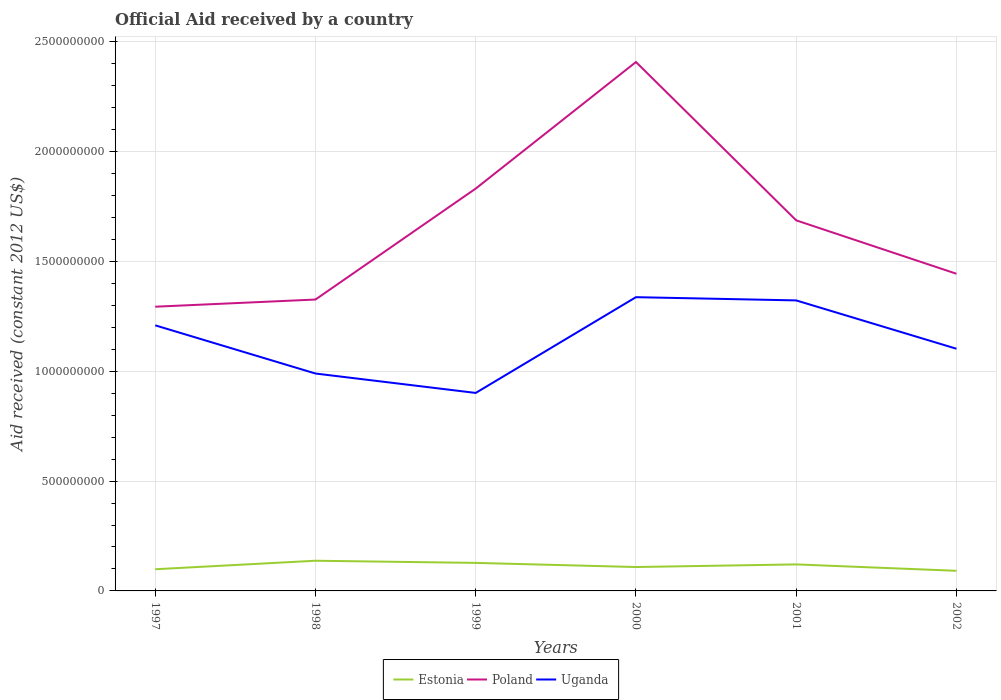How many different coloured lines are there?
Offer a very short reply. 3. Does the line corresponding to Estonia intersect with the line corresponding to Uganda?
Your answer should be compact. No. Across all years, what is the maximum net official aid received in Poland?
Make the answer very short. 1.29e+09. What is the total net official aid received in Poland in the graph?
Ensure brevity in your answer.  -3.93e+08. What is the difference between the highest and the second highest net official aid received in Estonia?
Give a very brief answer. 4.58e+07. Is the net official aid received in Poland strictly greater than the net official aid received in Uganda over the years?
Offer a very short reply. No. What is the difference between two consecutive major ticks on the Y-axis?
Offer a terse response. 5.00e+08. Does the graph contain any zero values?
Offer a very short reply. No. Does the graph contain grids?
Provide a succinct answer. Yes. How many legend labels are there?
Your response must be concise. 3. What is the title of the graph?
Offer a very short reply. Official Aid received by a country. Does "Finland" appear as one of the legend labels in the graph?
Provide a succinct answer. No. What is the label or title of the Y-axis?
Give a very brief answer. Aid received (constant 2012 US$). What is the Aid received (constant 2012 US$) in Estonia in 1997?
Make the answer very short. 9.87e+07. What is the Aid received (constant 2012 US$) of Poland in 1997?
Make the answer very short. 1.29e+09. What is the Aid received (constant 2012 US$) of Uganda in 1997?
Your response must be concise. 1.21e+09. What is the Aid received (constant 2012 US$) of Estonia in 1998?
Provide a short and direct response. 1.37e+08. What is the Aid received (constant 2012 US$) of Poland in 1998?
Your answer should be compact. 1.33e+09. What is the Aid received (constant 2012 US$) in Uganda in 1998?
Provide a short and direct response. 9.90e+08. What is the Aid received (constant 2012 US$) in Estonia in 1999?
Your response must be concise. 1.28e+08. What is the Aid received (constant 2012 US$) in Poland in 1999?
Your answer should be compact. 1.83e+09. What is the Aid received (constant 2012 US$) in Uganda in 1999?
Ensure brevity in your answer.  9.01e+08. What is the Aid received (constant 2012 US$) in Estonia in 2000?
Keep it short and to the point. 1.09e+08. What is the Aid received (constant 2012 US$) of Poland in 2000?
Your answer should be compact. 2.41e+09. What is the Aid received (constant 2012 US$) of Uganda in 2000?
Your answer should be very brief. 1.34e+09. What is the Aid received (constant 2012 US$) of Estonia in 2001?
Your answer should be very brief. 1.21e+08. What is the Aid received (constant 2012 US$) in Poland in 2001?
Your response must be concise. 1.69e+09. What is the Aid received (constant 2012 US$) in Uganda in 2001?
Your answer should be compact. 1.32e+09. What is the Aid received (constant 2012 US$) of Estonia in 2002?
Provide a short and direct response. 9.16e+07. What is the Aid received (constant 2012 US$) in Poland in 2002?
Your answer should be very brief. 1.44e+09. What is the Aid received (constant 2012 US$) of Uganda in 2002?
Give a very brief answer. 1.10e+09. Across all years, what is the maximum Aid received (constant 2012 US$) in Estonia?
Offer a terse response. 1.37e+08. Across all years, what is the maximum Aid received (constant 2012 US$) of Poland?
Your answer should be very brief. 2.41e+09. Across all years, what is the maximum Aid received (constant 2012 US$) of Uganda?
Offer a terse response. 1.34e+09. Across all years, what is the minimum Aid received (constant 2012 US$) of Estonia?
Give a very brief answer. 9.16e+07. Across all years, what is the minimum Aid received (constant 2012 US$) in Poland?
Give a very brief answer. 1.29e+09. Across all years, what is the minimum Aid received (constant 2012 US$) of Uganda?
Keep it short and to the point. 9.01e+08. What is the total Aid received (constant 2012 US$) of Estonia in the graph?
Give a very brief answer. 6.85e+08. What is the total Aid received (constant 2012 US$) in Poland in the graph?
Offer a very short reply. 9.99e+09. What is the total Aid received (constant 2012 US$) in Uganda in the graph?
Give a very brief answer. 6.86e+09. What is the difference between the Aid received (constant 2012 US$) in Estonia in 1997 and that in 1998?
Provide a short and direct response. -3.88e+07. What is the difference between the Aid received (constant 2012 US$) in Poland in 1997 and that in 1998?
Your answer should be compact. -3.26e+07. What is the difference between the Aid received (constant 2012 US$) in Uganda in 1997 and that in 1998?
Offer a terse response. 2.19e+08. What is the difference between the Aid received (constant 2012 US$) of Estonia in 1997 and that in 1999?
Your answer should be very brief. -2.89e+07. What is the difference between the Aid received (constant 2012 US$) in Poland in 1997 and that in 1999?
Your answer should be very brief. -5.38e+08. What is the difference between the Aid received (constant 2012 US$) of Uganda in 1997 and that in 1999?
Keep it short and to the point. 3.08e+08. What is the difference between the Aid received (constant 2012 US$) of Estonia in 1997 and that in 2000?
Keep it short and to the point. -1.00e+07. What is the difference between the Aid received (constant 2012 US$) of Poland in 1997 and that in 2000?
Make the answer very short. -1.11e+09. What is the difference between the Aid received (constant 2012 US$) of Uganda in 1997 and that in 2000?
Give a very brief answer. -1.28e+08. What is the difference between the Aid received (constant 2012 US$) in Estonia in 1997 and that in 2001?
Give a very brief answer. -2.20e+07. What is the difference between the Aid received (constant 2012 US$) of Poland in 1997 and that in 2001?
Provide a succinct answer. -3.93e+08. What is the difference between the Aid received (constant 2012 US$) of Uganda in 1997 and that in 2001?
Your answer should be compact. -1.14e+08. What is the difference between the Aid received (constant 2012 US$) in Estonia in 1997 and that in 2002?
Offer a very short reply. 7.07e+06. What is the difference between the Aid received (constant 2012 US$) of Poland in 1997 and that in 2002?
Offer a very short reply. -1.50e+08. What is the difference between the Aid received (constant 2012 US$) of Uganda in 1997 and that in 2002?
Your answer should be compact. 1.07e+08. What is the difference between the Aid received (constant 2012 US$) in Estonia in 1998 and that in 1999?
Provide a short and direct response. 9.86e+06. What is the difference between the Aid received (constant 2012 US$) in Poland in 1998 and that in 1999?
Provide a succinct answer. -5.05e+08. What is the difference between the Aid received (constant 2012 US$) of Uganda in 1998 and that in 1999?
Keep it short and to the point. 8.84e+07. What is the difference between the Aid received (constant 2012 US$) of Estonia in 1998 and that in 2000?
Provide a short and direct response. 2.87e+07. What is the difference between the Aid received (constant 2012 US$) of Poland in 1998 and that in 2000?
Your answer should be very brief. -1.08e+09. What is the difference between the Aid received (constant 2012 US$) of Uganda in 1998 and that in 2000?
Provide a succinct answer. -3.48e+08. What is the difference between the Aid received (constant 2012 US$) of Estonia in 1998 and that in 2001?
Offer a very short reply. 1.67e+07. What is the difference between the Aid received (constant 2012 US$) in Poland in 1998 and that in 2001?
Provide a succinct answer. -3.60e+08. What is the difference between the Aid received (constant 2012 US$) in Uganda in 1998 and that in 2001?
Your response must be concise. -3.33e+08. What is the difference between the Aid received (constant 2012 US$) in Estonia in 1998 and that in 2002?
Your response must be concise. 4.58e+07. What is the difference between the Aid received (constant 2012 US$) in Poland in 1998 and that in 2002?
Keep it short and to the point. -1.17e+08. What is the difference between the Aid received (constant 2012 US$) in Uganda in 1998 and that in 2002?
Provide a short and direct response. -1.13e+08. What is the difference between the Aid received (constant 2012 US$) in Estonia in 1999 and that in 2000?
Provide a succinct answer. 1.88e+07. What is the difference between the Aid received (constant 2012 US$) in Poland in 1999 and that in 2000?
Provide a short and direct response. -5.76e+08. What is the difference between the Aid received (constant 2012 US$) of Uganda in 1999 and that in 2000?
Offer a terse response. -4.36e+08. What is the difference between the Aid received (constant 2012 US$) in Estonia in 1999 and that in 2001?
Offer a very short reply. 6.84e+06. What is the difference between the Aid received (constant 2012 US$) of Poland in 1999 and that in 2001?
Keep it short and to the point. 1.45e+08. What is the difference between the Aid received (constant 2012 US$) in Uganda in 1999 and that in 2001?
Keep it short and to the point. -4.21e+08. What is the difference between the Aid received (constant 2012 US$) in Estonia in 1999 and that in 2002?
Keep it short and to the point. 3.60e+07. What is the difference between the Aid received (constant 2012 US$) in Poland in 1999 and that in 2002?
Provide a short and direct response. 3.88e+08. What is the difference between the Aid received (constant 2012 US$) of Uganda in 1999 and that in 2002?
Provide a succinct answer. -2.01e+08. What is the difference between the Aid received (constant 2012 US$) of Estonia in 2000 and that in 2001?
Offer a very short reply. -1.20e+07. What is the difference between the Aid received (constant 2012 US$) of Poland in 2000 and that in 2001?
Your answer should be compact. 7.21e+08. What is the difference between the Aid received (constant 2012 US$) of Uganda in 2000 and that in 2001?
Provide a short and direct response. 1.48e+07. What is the difference between the Aid received (constant 2012 US$) of Estonia in 2000 and that in 2002?
Offer a very short reply. 1.71e+07. What is the difference between the Aid received (constant 2012 US$) of Poland in 2000 and that in 2002?
Offer a terse response. 9.64e+08. What is the difference between the Aid received (constant 2012 US$) of Uganda in 2000 and that in 2002?
Offer a terse response. 2.35e+08. What is the difference between the Aid received (constant 2012 US$) of Estonia in 2001 and that in 2002?
Your answer should be compact. 2.91e+07. What is the difference between the Aid received (constant 2012 US$) of Poland in 2001 and that in 2002?
Ensure brevity in your answer.  2.43e+08. What is the difference between the Aid received (constant 2012 US$) in Uganda in 2001 and that in 2002?
Your answer should be compact. 2.20e+08. What is the difference between the Aid received (constant 2012 US$) in Estonia in 1997 and the Aid received (constant 2012 US$) in Poland in 1998?
Make the answer very short. -1.23e+09. What is the difference between the Aid received (constant 2012 US$) in Estonia in 1997 and the Aid received (constant 2012 US$) in Uganda in 1998?
Provide a short and direct response. -8.91e+08. What is the difference between the Aid received (constant 2012 US$) of Poland in 1997 and the Aid received (constant 2012 US$) of Uganda in 1998?
Ensure brevity in your answer.  3.04e+08. What is the difference between the Aid received (constant 2012 US$) of Estonia in 1997 and the Aid received (constant 2012 US$) of Poland in 1999?
Provide a short and direct response. -1.73e+09. What is the difference between the Aid received (constant 2012 US$) in Estonia in 1997 and the Aid received (constant 2012 US$) in Uganda in 1999?
Your answer should be compact. -8.03e+08. What is the difference between the Aid received (constant 2012 US$) of Poland in 1997 and the Aid received (constant 2012 US$) of Uganda in 1999?
Your response must be concise. 3.93e+08. What is the difference between the Aid received (constant 2012 US$) of Estonia in 1997 and the Aid received (constant 2012 US$) of Poland in 2000?
Your answer should be very brief. -2.31e+09. What is the difference between the Aid received (constant 2012 US$) in Estonia in 1997 and the Aid received (constant 2012 US$) in Uganda in 2000?
Provide a short and direct response. -1.24e+09. What is the difference between the Aid received (constant 2012 US$) of Poland in 1997 and the Aid received (constant 2012 US$) of Uganda in 2000?
Keep it short and to the point. -4.34e+07. What is the difference between the Aid received (constant 2012 US$) of Estonia in 1997 and the Aid received (constant 2012 US$) of Poland in 2001?
Make the answer very short. -1.59e+09. What is the difference between the Aid received (constant 2012 US$) in Estonia in 1997 and the Aid received (constant 2012 US$) in Uganda in 2001?
Offer a very short reply. -1.22e+09. What is the difference between the Aid received (constant 2012 US$) in Poland in 1997 and the Aid received (constant 2012 US$) in Uganda in 2001?
Make the answer very short. -2.86e+07. What is the difference between the Aid received (constant 2012 US$) in Estonia in 1997 and the Aid received (constant 2012 US$) in Poland in 2002?
Your answer should be compact. -1.35e+09. What is the difference between the Aid received (constant 2012 US$) of Estonia in 1997 and the Aid received (constant 2012 US$) of Uganda in 2002?
Offer a very short reply. -1.00e+09. What is the difference between the Aid received (constant 2012 US$) in Poland in 1997 and the Aid received (constant 2012 US$) in Uganda in 2002?
Ensure brevity in your answer.  1.91e+08. What is the difference between the Aid received (constant 2012 US$) of Estonia in 1998 and the Aid received (constant 2012 US$) of Poland in 1999?
Make the answer very short. -1.69e+09. What is the difference between the Aid received (constant 2012 US$) in Estonia in 1998 and the Aid received (constant 2012 US$) in Uganda in 1999?
Provide a succinct answer. -7.64e+08. What is the difference between the Aid received (constant 2012 US$) of Poland in 1998 and the Aid received (constant 2012 US$) of Uganda in 1999?
Give a very brief answer. 4.25e+08. What is the difference between the Aid received (constant 2012 US$) in Estonia in 1998 and the Aid received (constant 2012 US$) in Poland in 2000?
Provide a succinct answer. -2.27e+09. What is the difference between the Aid received (constant 2012 US$) in Estonia in 1998 and the Aid received (constant 2012 US$) in Uganda in 2000?
Your answer should be very brief. -1.20e+09. What is the difference between the Aid received (constant 2012 US$) of Poland in 1998 and the Aid received (constant 2012 US$) of Uganda in 2000?
Your response must be concise. -1.07e+07. What is the difference between the Aid received (constant 2012 US$) in Estonia in 1998 and the Aid received (constant 2012 US$) in Poland in 2001?
Your answer should be compact. -1.55e+09. What is the difference between the Aid received (constant 2012 US$) of Estonia in 1998 and the Aid received (constant 2012 US$) of Uganda in 2001?
Your answer should be very brief. -1.19e+09. What is the difference between the Aid received (constant 2012 US$) in Poland in 1998 and the Aid received (constant 2012 US$) in Uganda in 2001?
Keep it short and to the point. 4.02e+06. What is the difference between the Aid received (constant 2012 US$) in Estonia in 1998 and the Aid received (constant 2012 US$) in Poland in 2002?
Offer a very short reply. -1.31e+09. What is the difference between the Aid received (constant 2012 US$) of Estonia in 1998 and the Aid received (constant 2012 US$) of Uganda in 2002?
Offer a very short reply. -9.65e+08. What is the difference between the Aid received (constant 2012 US$) of Poland in 1998 and the Aid received (constant 2012 US$) of Uganda in 2002?
Make the answer very short. 2.24e+08. What is the difference between the Aid received (constant 2012 US$) in Estonia in 1999 and the Aid received (constant 2012 US$) in Poland in 2000?
Offer a terse response. -2.28e+09. What is the difference between the Aid received (constant 2012 US$) of Estonia in 1999 and the Aid received (constant 2012 US$) of Uganda in 2000?
Offer a terse response. -1.21e+09. What is the difference between the Aid received (constant 2012 US$) of Poland in 1999 and the Aid received (constant 2012 US$) of Uganda in 2000?
Your response must be concise. 4.94e+08. What is the difference between the Aid received (constant 2012 US$) in Estonia in 1999 and the Aid received (constant 2012 US$) in Poland in 2001?
Offer a very short reply. -1.56e+09. What is the difference between the Aid received (constant 2012 US$) of Estonia in 1999 and the Aid received (constant 2012 US$) of Uganda in 2001?
Make the answer very short. -1.20e+09. What is the difference between the Aid received (constant 2012 US$) in Poland in 1999 and the Aid received (constant 2012 US$) in Uganda in 2001?
Give a very brief answer. 5.09e+08. What is the difference between the Aid received (constant 2012 US$) in Estonia in 1999 and the Aid received (constant 2012 US$) in Poland in 2002?
Offer a very short reply. -1.32e+09. What is the difference between the Aid received (constant 2012 US$) of Estonia in 1999 and the Aid received (constant 2012 US$) of Uganda in 2002?
Your response must be concise. -9.75e+08. What is the difference between the Aid received (constant 2012 US$) of Poland in 1999 and the Aid received (constant 2012 US$) of Uganda in 2002?
Ensure brevity in your answer.  7.29e+08. What is the difference between the Aid received (constant 2012 US$) in Estonia in 2000 and the Aid received (constant 2012 US$) in Poland in 2001?
Make the answer very short. -1.58e+09. What is the difference between the Aid received (constant 2012 US$) in Estonia in 2000 and the Aid received (constant 2012 US$) in Uganda in 2001?
Your response must be concise. -1.21e+09. What is the difference between the Aid received (constant 2012 US$) in Poland in 2000 and the Aid received (constant 2012 US$) in Uganda in 2001?
Make the answer very short. 1.09e+09. What is the difference between the Aid received (constant 2012 US$) of Estonia in 2000 and the Aid received (constant 2012 US$) of Poland in 2002?
Give a very brief answer. -1.34e+09. What is the difference between the Aid received (constant 2012 US$) of Estonia in 2000 and the Aid received (constant 2012 US$) of Uganda in 2002?
Offer a terse response. -9.94e+08. What is the difference between the Aid received (constant 2012 US$) of Poland in 2000 and the Aid received (constant 2012 US$) of Uganda in 2002?
Offer a terse response. 1.31e+09. What is the difference between the Aid received (constant 2012 US$) in Estonia in 2001 and the Aid received (constant 2012 US$) in Poland in 2002?
Your answer should be compact. -1.32e+09. What is the difference between the Aid received (constant 2012 US$) of Estonia in 2001 and the Aid received (constant 2012 US$) of Uganda in 2002?
Your response must be concise. -9.82e+08. What is the difference between the Aid received (constant 2012 US$) of Poland in 2001 and the Aid received (constant 2012 US$) of Uganda in 2002?
Your response must be concise. 5.85e+08. What is the average Aid received (constant 2012 US$) in Estonia per year?
Provide a short and direct response. 1.14e+08. What is the average Aid received (constant 2012 US$) in Poland per year?
Make the answer very short. 1.67e+09. What is the average Aid received (constant 2012 US$) in Uganda per year?
Your response must be concise. 1.14e+09. In the year 1997, what is the difference between the Aid received (constant 2012 US$) of Estonia and Aid received (constant 2012 US$) of Poland?
Provide a short and direct response. -1.20e+09. In the year 1997, what is the difference between the Aid received (constant 2012 US$) of Estonia and Aid received (constant 2012 US$) of Uganda?
Ensure brevity in your answer.  -1.11e+09. In the year 1997, what is the difference between the Aid received (constant 2012 US$) in Poland and Aid received (constant 2012 US$) in Uganda?
Keep it short and to the point. 8.49e+07. In the year 1998, what is the difference between the Aid received (constant 2012 US$) of Estonia and Aid received (constant 2012 US$) of Poland?
Keep it short and to the point. -1.19e+09. In the year 1998, what is the difference between the Aid received (constant 2012 US$) in Estonia and Aid received (constant 2012 US$) in Uganda?
Provide a succinct answer. -8.52e+08. In the year 1998, what is the difference between the Aid received (constant 2012 US$) of Poland and Aid received (constant 2012 US$) of Uganda?
Your answer should be compact. 3.37e+08. In the year 1999, what is the difference between the Aid received (constant 2012 US$) of Estonia and Aid received (constant 2012 US$) of Poland?
Keep it short and to the point. -1.70e+09. In the year 1999, what is the difference between the Aid received (constant 2012 US$) in Estonia and Aid received (constant 2012 US$) in Uganda?
Your answer should be very brief. -7.74e+08. In the year 1999, what is the difference between the Aid received (constant 2012 US$) in Poland and Aid received (constant 2012 US$) in Uganda?
Offer a very short reply. 9.30e+08. In the year 2000, what is the difference between the Aid received (constant 2012 US$) in Estonia and Aid received (constant 2012 US$) in Poland?
Provide a succinct answer. -2.30e+09. In the year 2000, what is the difference between the Aid received (constant 2012 US$) in Estonia and Aid received (constant 2012 US$) in Uganda?
Offer a very short reply. -1.23e+09. In the year 2000, what is the difference between the Aid received (constant 2012 US$) in Poland and Aid received (constant 2012 US$) in Uganda?
Keep it short and to the point. 1.07e+09. In the year 2001, what is the difference between the Aid received (constant 2012 US$) in Estonia and Aid received (constant 2012 US$) in Poland?
Make the answer very short. -1.57e+09. In the year 2001, what is the difference between the Aid received (constant 2012 US$) of Estonia and Aid received (constant 2012 US$) of Uganda?
Ensure brevity in your answer.  -1.20e+09. In the year 2001, what is the difference between the Aid received (constant 2012 US$) of Poland and Aid received (constant 2012 US$) of Uganda?
Your answer should be very brief. 3.64e+08. In the year 2002, what is the difference between the Aid received (constant 2012 US$) in Estonia and Aid received (constant 2012 US$) in Poland?
Make the answer very short. -1.35e+09. In the year 2002, what is the difference between the Aid received (constant 2012 US$) of Estonia and Aid received (constant 2012 US$) of Uganda?
Provide a succinct answer. -1.01e+09. In the year 2002, what is the difference between the Aid received (constant 2012 US$) of Poland and Aid received (constant 2012 US$) of Uganda?
Offer a very short reply. 3.41e+08. What is the ratio of the Aid received (constant 2012 US$) in Estonia in 1997 to that in 1998?
Your answer should be compact. 0.72. What is the ratio of the Aid received (constant 2012 US$) of Poland in 1997 to that in 1998?
Keep it short and to the point. 0.98. What is the ratio of the Aid received (constant 2012 US$) in Uganda in 1997 to that in 1998?
Your answer should be compact. 1.22. What is the ratio of the Aid received (constant 2012 US$) in Estonia in 1997 to that in 1999?
Offer a terse response. 0.77. What is the ratio of the Aid received (constant 2012 US$) in Poland in 1997 to that in 1999?
Your response must be concise. 0.71. What is the ratio of the Aid received (constant 2012 US$) in Uganda in 1997 to that in 1999?
Provide a succinct answer. 1.34. What is the ratio of the Aid received (constant 2012 US$) of Estonia in 1997 to that in 2000?
Your answer should be very brief. 0.91. What is the ratio of the Aid received (constant 2012 US$) in Poland in 1997 to that in 2000?
Offer a terse response. 0.54. What is the ratio of the Aid received (constant 2012 US$) of Uganda in 1997 to that in 2000?
Your answer should be very brief. 0.9. What is the ratio of the Aid received (constant 2012 US$) of Estonia in 1997 to that in 2001?
Keep it short and to the point. 0.82. What is the ratio of the Aid received (constant 2012 US$) of Poland in 1997 to that in 2001?
Your response must be concise. 0.77. What is the ratio of the Aid received (constant 2012 US$) of Uganda in 1997 to that in 2001?
Ensure brevity in your answer.  0.91. What is the ratio of the Aid received (constant 2012 US$) of Estonia in 1997 to that in 2002?
Offer a terse response. 1.08. What is the ratio of the Aid received (constant 2012 US$) of Poland in 1997 to that in 2002?
Ensure brevity in your answer.  0.9. What is the ratio of the Aid received (constant 2012 US$) of Uganda in 1997 to that in 2002?
Keep it short and to the point. 1.1. What is the ratio of the Aid received (constant 2012 US$) of Estonia in 1998 to that in 1999?
Your response must be concise. 1.08. What is the ratio of the Aid received (constant 2012 US$) of Poland in 1998 to that in 1999?
Offer a terse response. 0.72. What is the ratio of the Aid received (constant 2012 US$) in Uganda in 1998 to that in 1999?
Your answer should be very brief. 1.1. What is the ratio of the Aid received (constant 2012 US$) of Estonia in 1998 to that in 2000?
Offer a very short reply. 1.26. What is the ratio of the Aid received (constant 2012 US$) of Poland in 1998 to that in 2000?
Your answer should be compact. 0.55. What is the ratio of the Aid received (constant 2012 US$) of Uganda in 1998 to that in 2000?
Ensure brevity in your answer.  0.74. What is the ratio of the Aid received (constant 2012 US$) of Estonia in 1998 to that in 2001?
Offer a very short reply. 1.14. What is the ratio of the Aid received (constant 2012 US$) in Poland in 1998 to that in 2001?
Your response must be concise. 0.79. What is the ratio of the Aid received (constant 2012 US$) in Uganda in 1998 to that in 2001?
Give a very brief answer. 0.75. What is the ratio of the Aid received (constant 2012 US$) in Estonia in 1998 to that in 2002?
Your answer should be very brief. 1.5. What is the ratio of the Aid received (constant 2012 US$) in Poland in 1998 to that in 2002?
Offer a terse response. 0.92. What is the ratio of the Aid received (constant 2012 US$) in Uganda in 1998 to that in 2002?
Provide a succinct answer. 0.9. What is the ratio of the Aid received (constant 2012 US$) of Estonia in 1999 to that in 2000?
Offer a terse response. 1.17. What is the ratio of the Aid received (constant 2012 US$) of Poland in 1999 to that in 2000?
Give a very brief answer. 0.76. What is the ratio of the Aid received (constant 2012 US$) in Uganda in 1999 to that in 2000?
Offer a very short reply. 0.67. What is the ratio of the Aid received (constant 2012 US$) in Estonia in 1999 to that in 2001?
Ensure brevity in your answer.  1.06. What is the ratio of the Aid received (constant 2012 US$) in Poland in 1999 to that in 2001?
Provide a succinct answer. 1.09. What is the ratio of the Aid received (constant 2012 US$) in Uganda in 1999 to that in 2001?
Offer a terse response. 0.68. What is the ratio of the Aid received (constant 2012 US$) of Estonia in 1999 to that in 2002?
Give a very brief answer. 1.39. What is the ratio of the Aid received (constant 2012 US$) in Poland in 1999 to that in 2002?
Keep it short and to the point. 1.27. What is the ratio of the Aid received (constant 2012 US$) in Uganda in 1999 to that in 2002?
Offer a terse response. 0.82. What is the ratio of the Aid received (constant 2012 US$) of Estonia in 2000 to that in 2001?
Your answer should be compact. 0.9. What is the ratio of the Aid received (constant 2012 US$) of Poland in 2000 to that in 2001?
Offer a very short reply. 1.43. What is the ratio of the Aid received (constant 2012 US$) of Uganda in 2000 to that in 2001?
Provide a succinct answer. 1.01. What is the ratio of the Aid received (constant 2012 US$) of Estonia in 2000 to that in 2002?
Give a very brief answer. 1.19. What is the ratio of the Aid received (constant 2012 US$) of Poland in 2000 to that in 2002?
Offer a terse response. 1.67. What is the ratio of the Aid received (constant 2012 US$) of Uganda in 2000 to that in 2002?
Offer a terse response. 1.21. What is the ratio of the Aid received (constant 2012 US$) of Estonia in 2001 to that in 2002?
Your response must be concise. 1.32. What is the ratio of the Aid received (constant 2012 US$) in Poland in 2001 to that in 2002?
Your response must be concise. 1.17. What is the ratio of the Aid received (constant 2012 US$) in Uganda in 2001 to that in 2002?
Ensure brevity in your answer.  1.2. What is the difference between the highest and the second highest Aid received (constant 2012 US$) of Estonia?
Offer a very short reply. 9.86e+06. What is the difference between the highest and the second highest Aid received (constant 2012 US$) in Poland?
Provide a short and direct response. 5.76e+08. What is the difference between the highest and the second highest Aid received (constant 2012 US$) in Uganda?
Offer a very short reply. 1.48e+07. What is the difference between the highest and the lowest Aid received (constant 2012 US$) in Estonia?
Offer a very short reply. 4.58e+07. What is the difference between the highest and the lowest Aid received (constant 2012 US$) in Poland?
Your response must be concise. 1.11e+09. What is the difference between the highest and the lowest Aid received (constant 2012 US$) in Uganda?
Provide a short and direct response. 4.36e+08. 